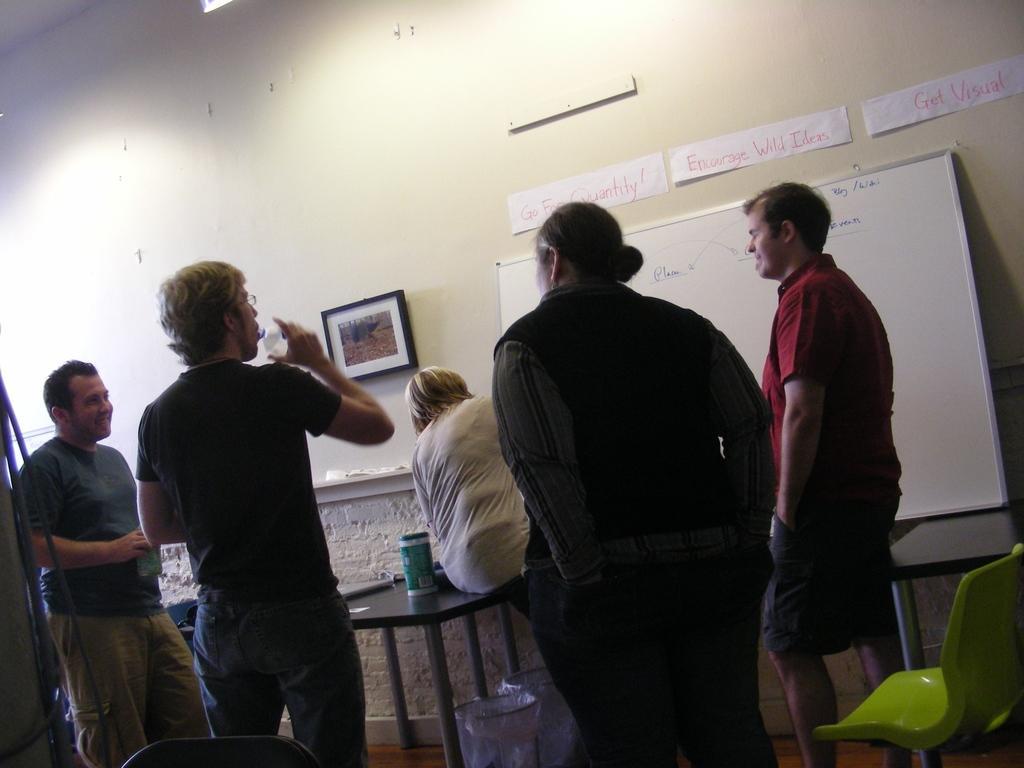Describe this image in one or two sentences. In this image I can see few people are standing in-front of the table. And I can see one person is sitting on the table. These people are wearing the different color dresses and one person is holding the bottle. To the right I can see the green color chair and there are two dustbins under the table. In the back there are frames and borders to the white wall. 